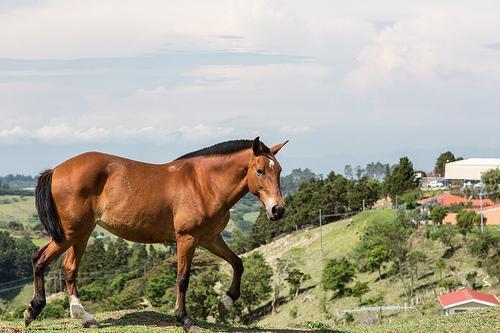How many people are riding horses?
Give a very brief answer. 0. How many horses are there?
Give a very brief answer. 1. 